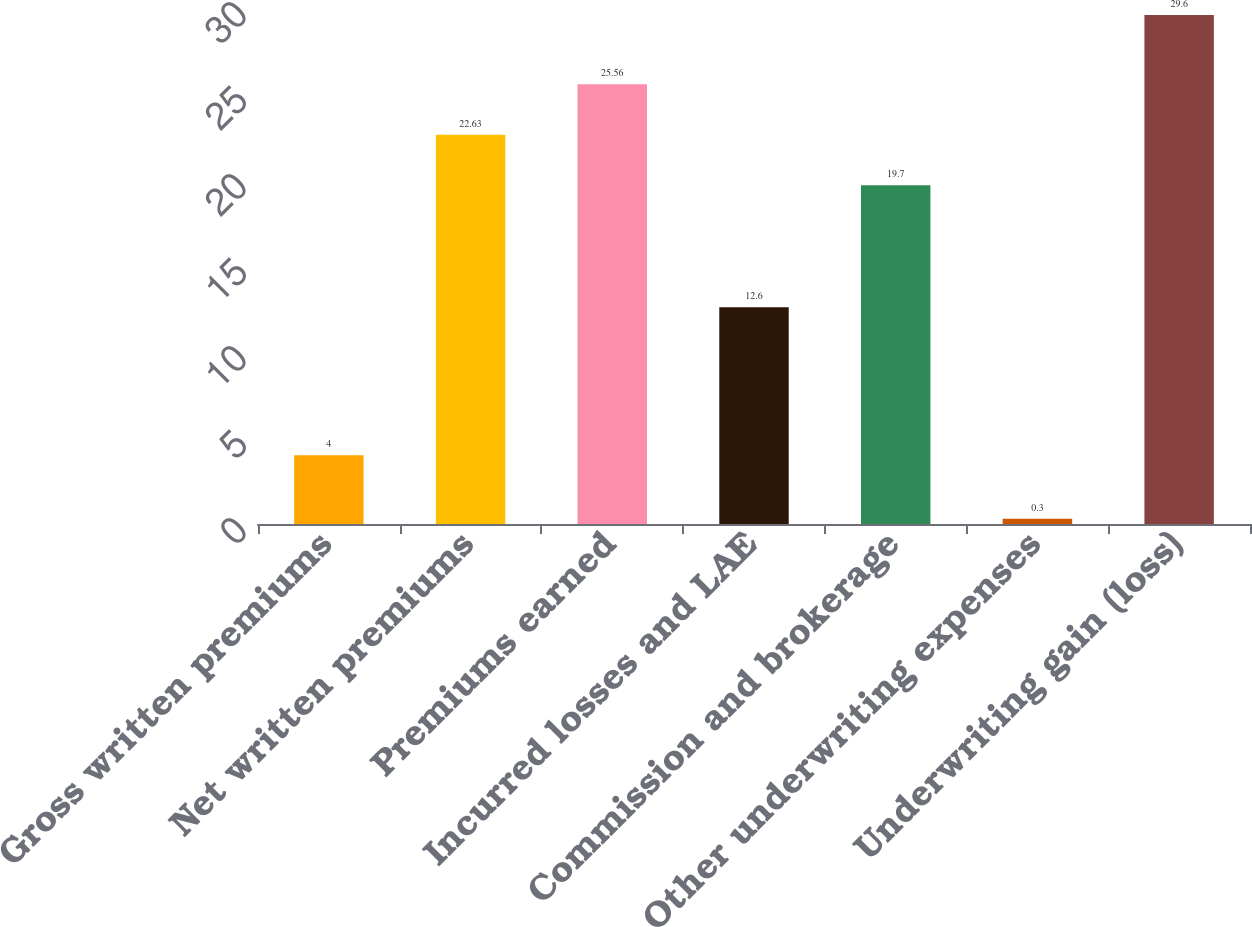<chart> <loc_0><loc_0><loc_500><loc_500><bar_chart><fcel>Gross written premiums<fcel>Net written premiums<fcel>Premiums earned<fcel>Incurred losses and LAE<fcel>Commission and brokerage<fcel>Other underwriting expenses<fcel>Underwriting gain (loss)<nl><fcel>4<fcel>22.63<fcel>25.56<fcel>12.6<fcel>19.7<fcel>0.3<fcel>29.6<nl></chart> 